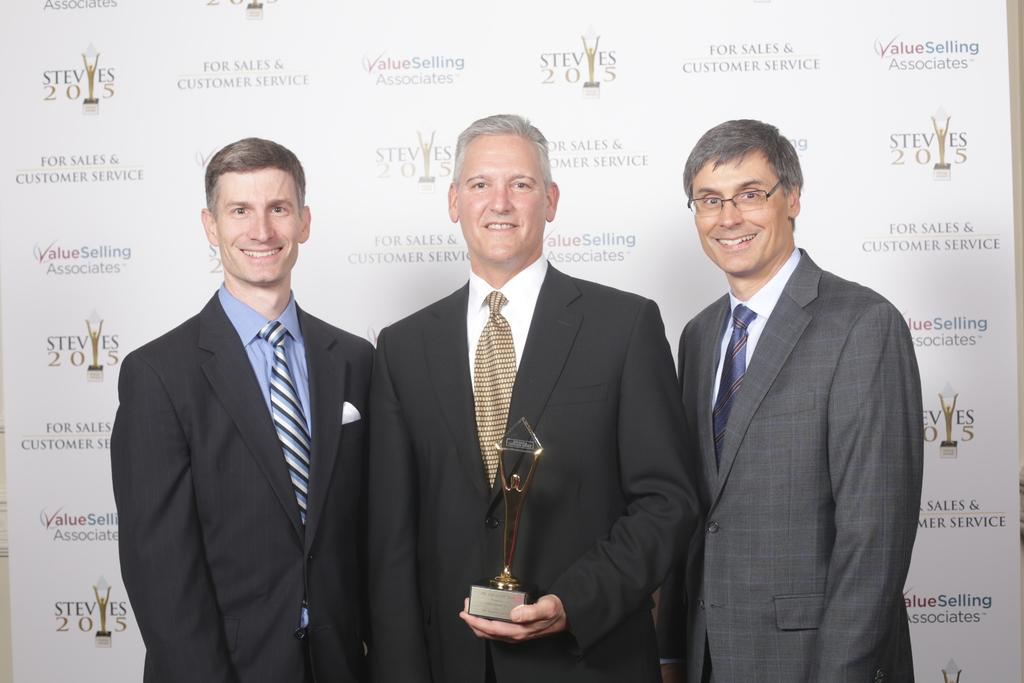How many people are in the image? There are three persons standing in the image. What is the facial expression of the people in the image? The persons are smiling. What is the middle person holding in the image? The middle person is holding an object. What can be seen in the background of the image? There is a poster with text in the background of the image. What type of jellyfish can be seen swimming in the image? There are no jellyfish present in the image; it features three people standing and smiling. What is the purpose of the turkey in the image? There is no turkey present in the image, so it is not possible to determine its purpose. 